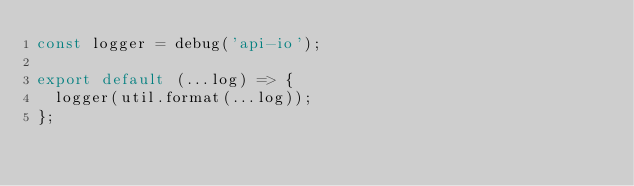Convert code to text. <code><loc_0><loc_0><loc_500><loc_500><_JavaScript_>const logger = debug('api-io');

export default (...log) => {
  logger(util.format(...log));
};
</code> 